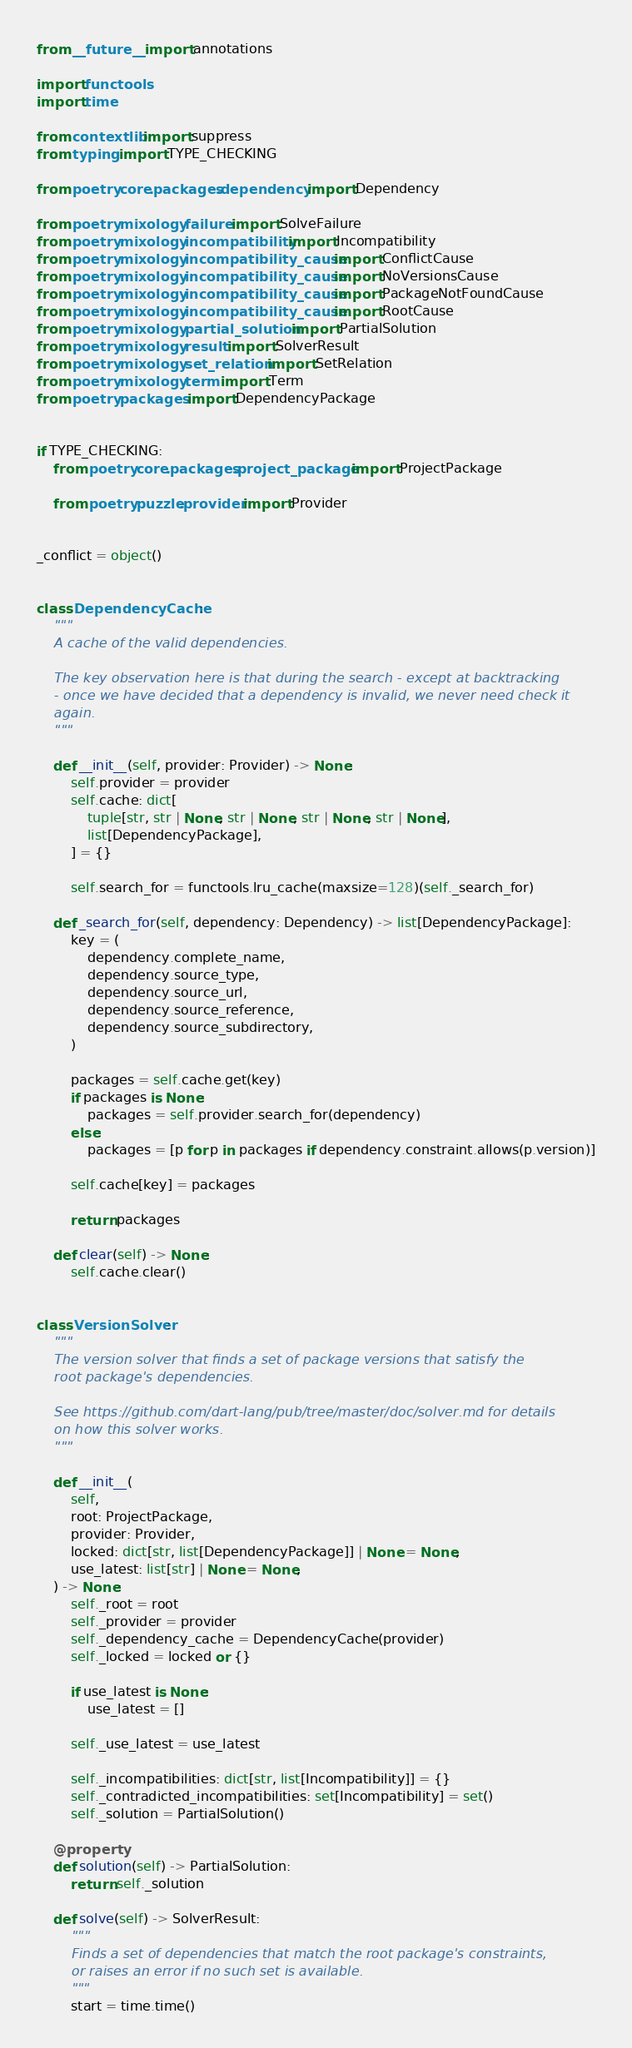<code> <loc_0><loc_0><loc_500><loc_500><_Python_>from __future__ import annotations

import functools
import time

from contextlib import suppress
from typing import TYPE_CHECKING

from poetry.core.packages.dependency import Dependency

from poetry.mixology.failure import SolveFailure
from poetry.mixology.incompatibility import Incompatibility
from poetry.mixology.incompatibility_cause import ConflictCause
from poetry.mixology.incompatibility_cause import NoVersionsCause
from poetry.mixology.incompatibility_cause import PackageNotFoundCause
from poetry.mixology.incompatibility_cause import RootCause
from poetry.mixology.partial_solution import PartialSolution
from poetry.mixology.result import SolverResult
from poetry.mixology.set_relation import SetRelation
from poetry.mixology.term import Term
from poetry.packages import DependencyPackage


if TYPE_CHECKING:
    from poetry.core.packages.project_package import ProjectPackage

    from poetry.puzzle.provider import Provider


_conflict = object()


class DependencyCache:
    """
    A cache of the valid dependencies.

    The key observation here is that during the search - except at backtracking
    - once we have decided that a dependency is invalid, we never need check it
    again.
    """

    def __init__(self, provider: Provider) -> None:
        self.provider = provider
        self.cache: dict[
            tuple[str, str | None, str | None, str | None, str | None],
            list[DependencyPackage],
        ] = {}

        self.search_for = functools.lru_cache(maxsize=128)(self._search_for)

    def _search_for(self, dependency: Dependency) -> list[DependencyPackage]:
        key = (
            dependency.complete_name,
            dependency.source_type,
            dependency.source_url,
            dependency.source_reference,
            dependency.source_subdirectory,
        )

        packages = self.cache.get(key)
        if packages is None:
            packages = self.provider.search_for(dependency)
        else:
            packages = [p for p in packages if dependency.constraint.allows(p.version)]

        self.cache[key] = packages

        return packages

    def clear(self) -> None:
        self.cache.clear()


class VersionSolver:
    """
    The version solver that finds a set of package versions that satisfy the
    root package's dependencies.

    See https://github.com/dart-lang/pub/tree/master/doc/solver.md for details
    on how this solver works.
    """

    def __init__(
        self,
        root: ProjectPackage,
        provider: Provider,
        locked: dict[str, list[DependencyPackage]] | None = None,
        use_latest: list[str] | None = None,
    ) -> None:
        self._root = root
        self._provider = provider
        self._dependency_cache = DependencyCache(provider)
        self._locked = locked or {}

        if use_latest is None:
            use_latest = []

        self._use_latest = use_latest

        self._incompatibilities: dict[str, list[Incompatibility]] = {}
        self._contradicted_incompatibilities: set[Incompatibility] = set()
        self._solution = PartialSolution()

    @property
    def solution(self) -> PartialSolution:
        return self._solution

    def solve(self) -> SolverResult:
        """
        Finds a set of dependencies that match the root package's constraints,
        or raises an error if no such set is available.
        """
        start = time.time()</code> 